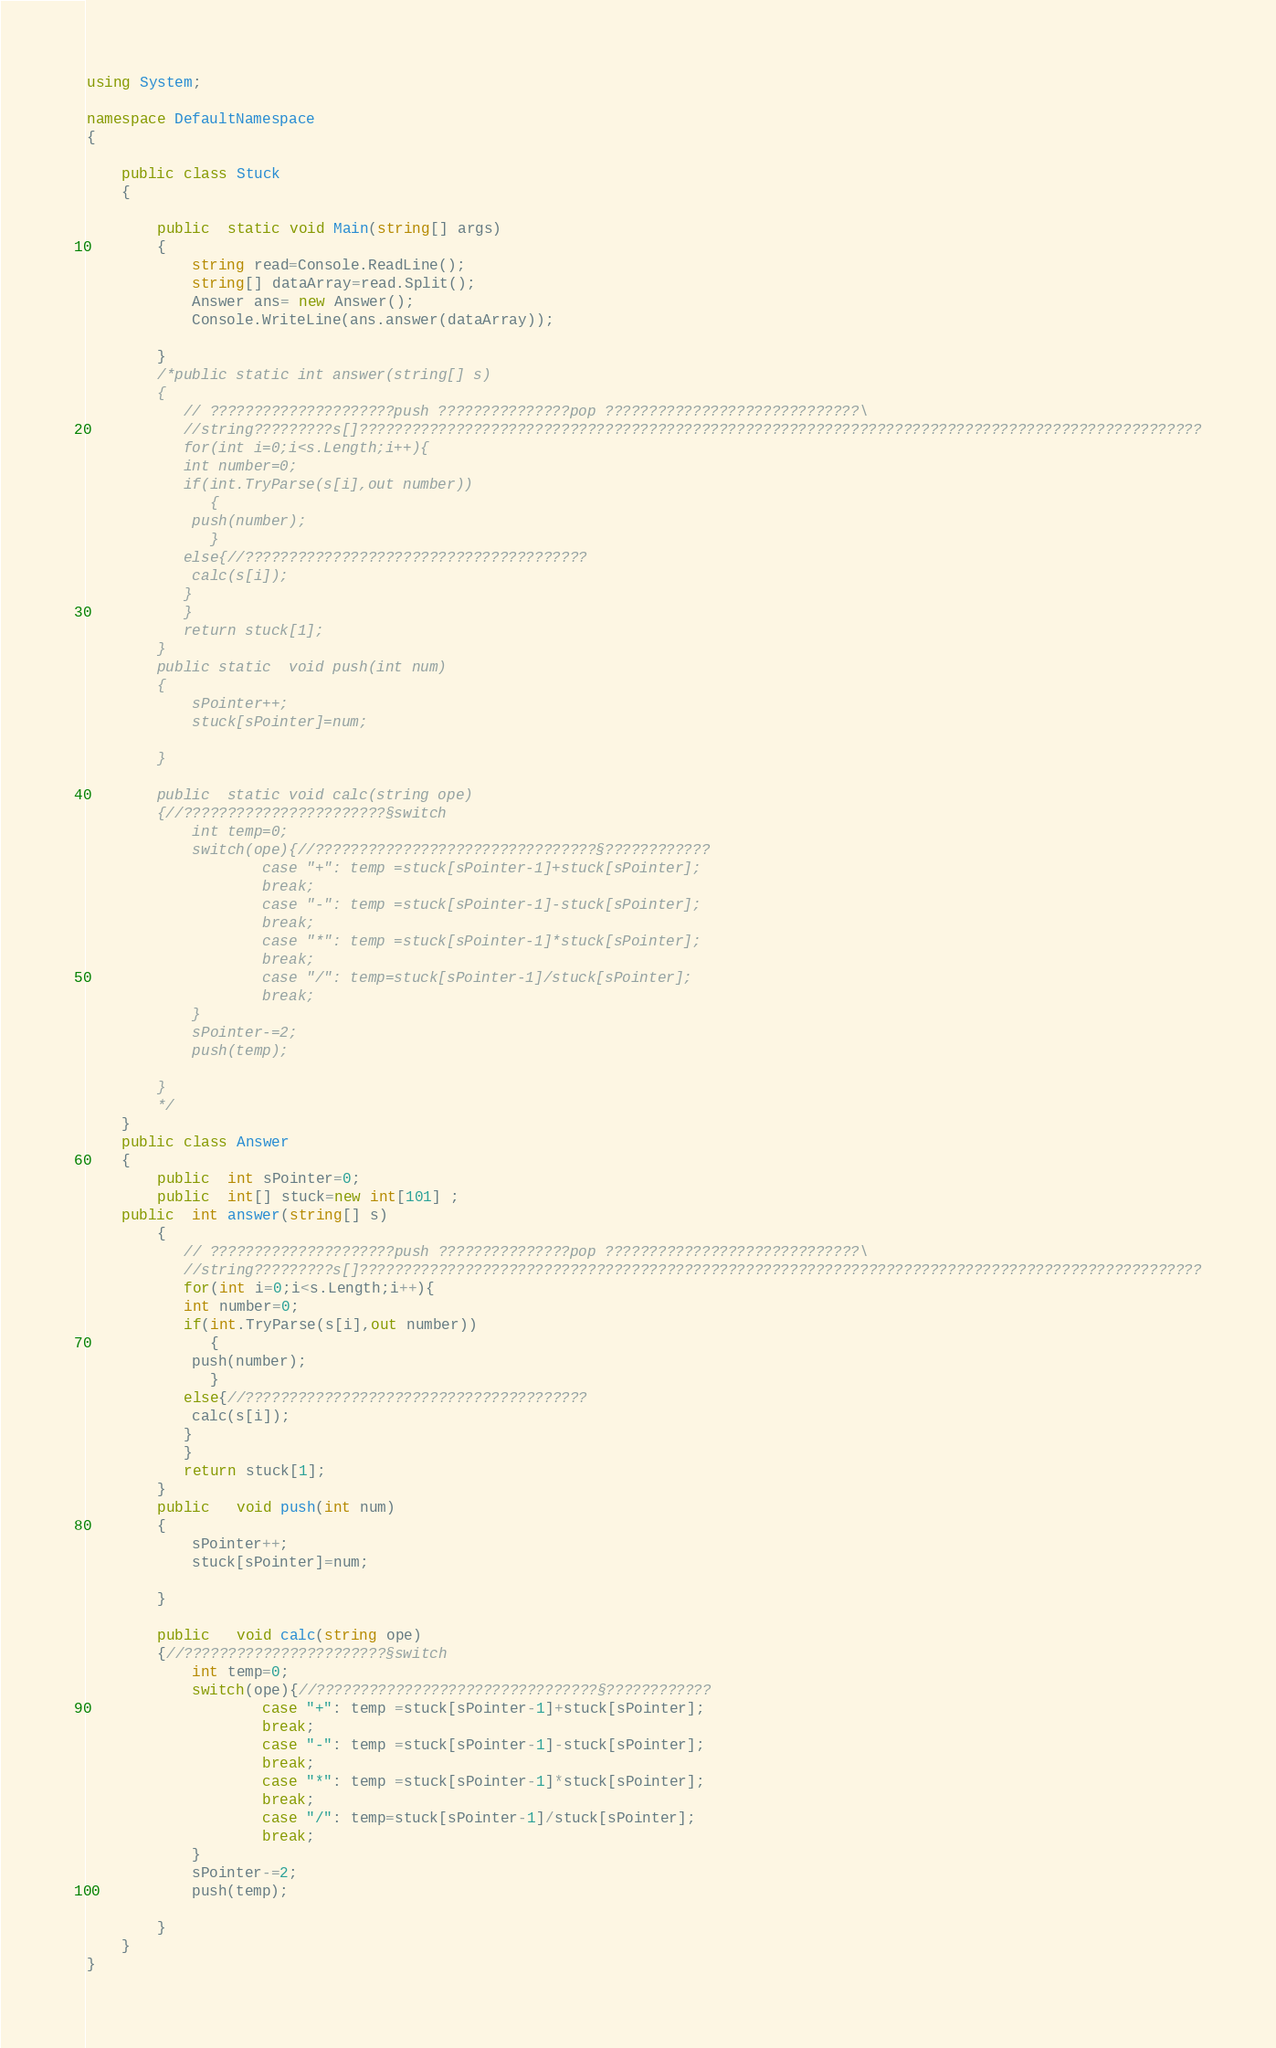Convert code to text. <code><loc_0><loc_0><loc_500><loc_500><_C#_>using System;

namespace DefaultNamespace
{
	
	public class Stuck
	{
		
		public  static void Main(string[] args)
		{
			string read=Console.ReadLine();
			string[] dataArray=read.Split();
			Answer ans= new Answer();
			Console.WriteLine(ans.answer(dataArray));
			
		}
		/*public static int answer(string[] s)
		{
		   // ?????????????????????push ???????????????pop ?????????????????????????????\
		   //string?????????s[]????????????????????????????????????????????????????????????????????????????????????????????????
		   for(int i=0;i<s.Length;i++){
		   int number=0;
		   if(int.TryParse(s[i],out number))
		      {
		   	push(number);
		      }
		   else{//???????????????????????????????????????
		   	calc(s[i]);
		   }
		   }
		   return stuck[1];
		}
		public static  void push(int num)
		{
			sPointer++;
			stuck[sPointer]=num;
			
		}
		
		public  static void calc(string ope)
		{//???????????????????????§switch
			int temp=0;
			switch(ope){//????????????????????????????????§????????????
					case "+": temp =stuck[sPointer-1]+stuck[sPointer];
					break;
					case "-": temp =stuck[sPointer-1]-stuck[sPointer];
					break;
					case "*": temp =stuck[sPointer-1]*stuck[sPointer];
					break;
					case "/": temp=stuck[sPointer-1]/stuck[sPointer];
					break;
			}
			sPointer-=2;
			push(temp);
			
		}
		*/
	}
	public class Answer
	{
		public  int sPointer=0;
		public  int[] stuck=new int[101] ;
	public  int answer(string[] s)
		{
		   // ?????????????????????push ???????????????pop ?????????????????????????????\
		   //string?????????s[]????????????????????????????????????????????????????????????????????????????????????????????????
		   for(int i=0;i<s.Length;i++){
		   int number=0;
		   if(int.TryParse(s[i],out number))
		      {
		   	push(number);
		      }
		   else{//???????????????????????????????????????
		   	calc(s[i]);
		   }
		   }
		   return stuck[1];
		}
		public   void push(int num)
		{
			sPointer++;
			stuck[sPointer]=num;
			
		}
		
		public   void calc(string ope)
		{//???????????????????????§switch
			int temp=0;
			switch(ope){//????????????????????????????????§????????????
					case "+": temp =stuck[sPointer-1]+stuck[sPointer];
					break;
					case "-": temp =stuck[sPointer-1]-stuck[sPointer];
					break;
					case "*": temp =stuck[sPointer-1]*stuck[sPointer];
					break;
					case "/": temp=stuck[sPointer-1]/stuck[sPointer];
					break;
			}
			sPointer-=2;
			push(temp);
			
		}
	}
}</code> 